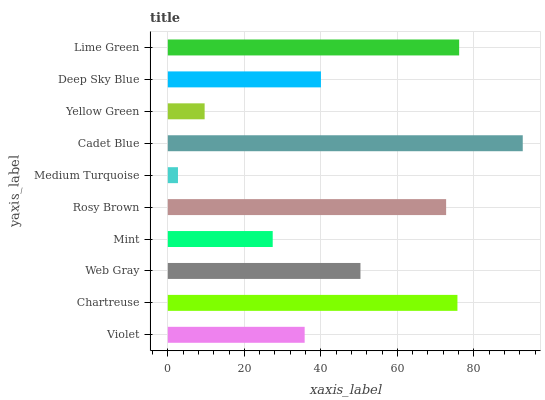Is Medium Turquoise the minimum?
Answer yes or no. Yes. Is Cadet Blue the maximum?
Answer yes or no. Yes. Is Chartreuse the minimum?
Answer yes or no. No. Is Chartreuse the maximum?
Answer yes or no. No. Is Chartreuse greater than Violet?
Answer yes or no. Yes. Is Violet less than Chartreuse?
Answer yes or no. Yes. Is Violet greater than Chartreuse?
Answer yes or no. No. Is Chartreuse less than Violet?
Answer yes or no. No. Is Web Gray the high median?
Answer yes or no. Yes. Is Deep Sky Blue the low median?
Answer yes or no. Yes. Is Chartreuse the high median?
Answer yes or no. No. Is Mint the low median?
Answer yes or no. No. 